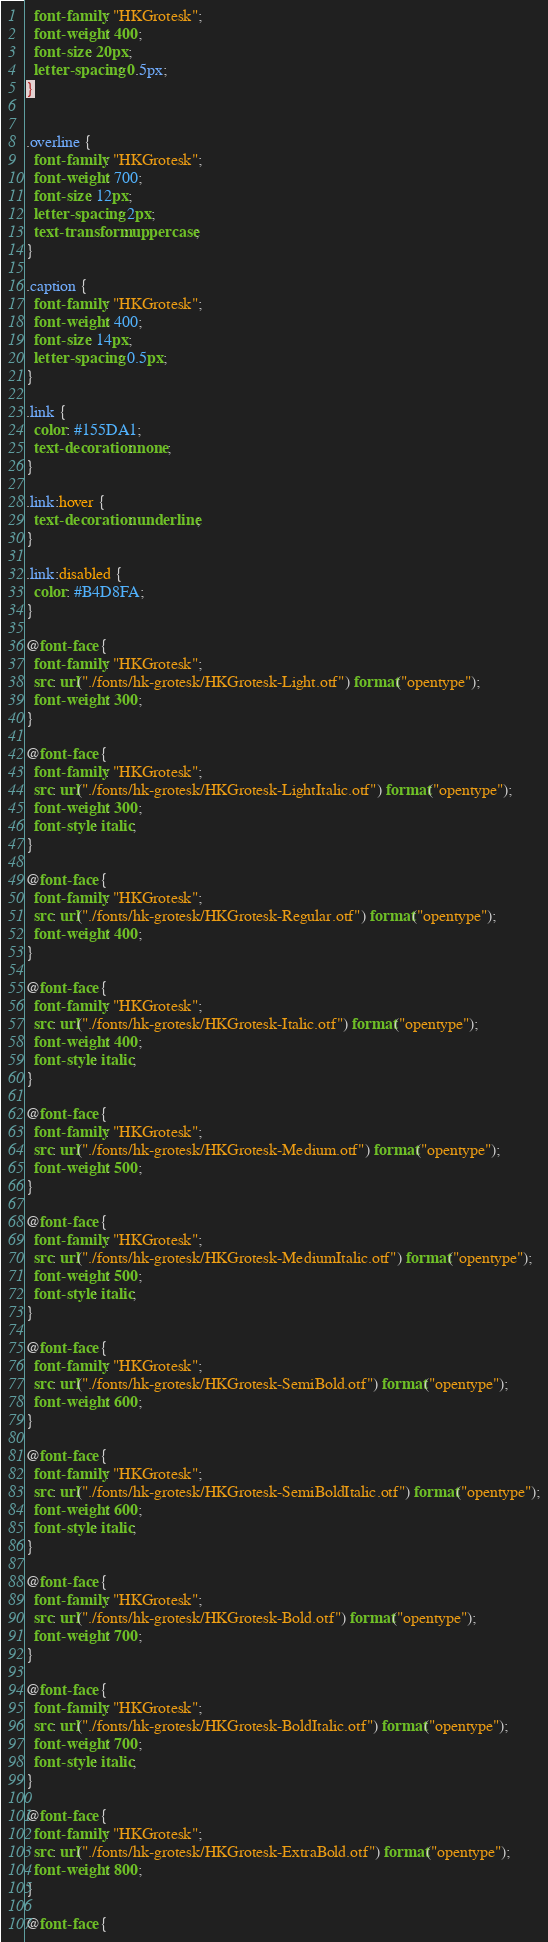Convert code to text. <code><loc_0><loc_0><loc_500><loc_500><_CSS_>  font-family: "HKGrotesk";
  font-weight: 400;
  font-size: 20px;
  letter-spacing: 0.5px;
}


.overline {
  font-family: "HKGrotesk";
  font-weight: 700;
  font-size: 12px;
  letter-spacing: 2px;
  text-transform: uppercase;
}

.caption {
  font-family: "HKGrotesk";
  font-weight: 400;
  font-size: 14px;
  letter-spacing: 0.5px;
}

.link {
  color: #155DA1;
  text-decoration: none;
}

.link:hover {
  text-decoration: underline;
}

.link:disabled {
  color: #B4D8FA;
}

@font-face {
  font-family: "HKGrotesk";
  src: url("./fonts/hk-grotesk/HKGrotesk-Light.otf") format("opentype");
  font-weight: 300;
}

@font-face {
  font-family: "HKGrotesk";
  src: url("./fonts/hk-grotesk/HKGrotesk-LightItalic.otf") format("opentype");
  font-weight: 300;
  font-style: italic;
}

@font-face {
  font-family: "HKGrotesk";
  src: url("./fonts/hk-grotesk/HKGrotesk-Regular.otf") format("opentype");
  font-weight: 400;
}

@font-face {
  font-family: "HKGrotesk";
  src: url("./fonts/hk-grotesk/HKGrotesk-Italic.otf") format("opentype");
  font-weight: 400;
  font-style: italic;
}

@font-face {
  font-family: "HKGrotesk";
  src: url("./fonts/hk-grotesk/HKGrotesk-Medium.otf") format("opentype");
  font-weight: 500;
}

@font-face {
  font-family: "HKGrotesk";
  src: url("./fonts/hk-grotesk/HKGrotesk-MediumItalic.otf") format("opentype");
  font-weight: 500;
  font-style: italic;
}

@font-face {
  font-family: "HKGrotesk";
  src: url("./fonts/hk-grotesk/HKGrotesk-SemiBold.otf") format("opentype");
  font-weight: 600;
}

@font-face {
  font-family: "HKGrotesk";
  src: url("./fonts/hk-grotesk/HKGrotesk-SemiBoldItalic.otf") format("opentype");
  font-weight: 600;
  font-style: italic;
}

@font-face {
  font-family: "HKGrotesk";
  src: url("./fonts/hk-grotesk/HKGrotesk-Bold.otf") format("opentype");
  font-weight: 700;
}

@font-face {
  font-family: "HKGrotesk";
  src: url("./fonts/hk-grotesk/HKGrotesk-BoldItalic.otf") format("opentype");
  font-weight: 700;
  font-style: italic;
}

@font-face {
  font-family: "HKGrotesk";
  src: url("./fonts/hk-grotesk/HKGrotesk-ExtraBold.otf") format("opentype");
  font-weight: 800;
}

@font-face {</code> 